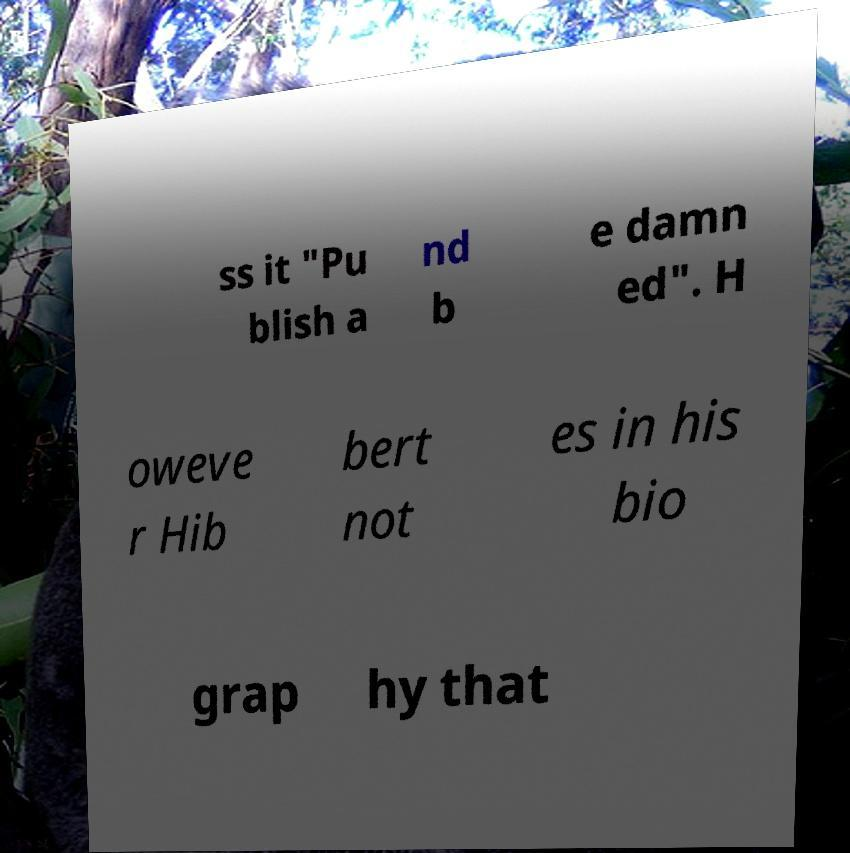Can you read and provide the text displayed in the image?This photo seems to have some interesting text. Can you extract and type it out for me? ss it "Pu blish a nd b e damn ed". H oweve r Hib bert not es in his bio grap hy that 